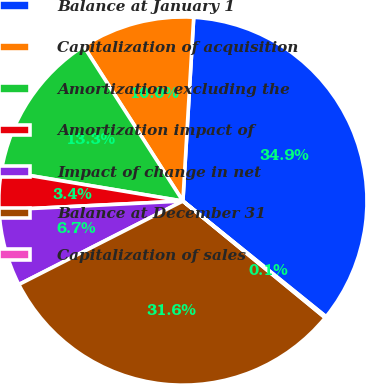<chart> <loc_0><loc_0><loc_500><loc_500><pie_chart><fcel>Balance at January 1<fcel>Capitalization of acquisition<fcel>Amortization excluding the<fcel>Amortization impact of<fcel>Impact of change in net<fcel>Balance at December 31<fcel>Capitalization of sales<nl><fcel>34.88%<fcel>10.01%<fcel>13.3%<fcel>3.41%<fcel>6.71%<fcel>31.58%<fcel>0.12%<nl></chart> 